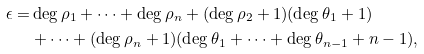Convert formula to latex. <formula><loc_0><loc_0><loc_500><loc_500>\epsilon = & \deg \rho _ { 1 } + \dots + \deg \rho _ { n } + ( \deg \rho _ { 2 } + 1 ) ( \deg \theta _ { 1 } + 1 ) \\ & + \dots + ( \deg \rho _ { n } + 1 ) ( \deg \theta _ { 1 } + \dots + \deg \theta _ { n - 1 } + n - 1 ) ,</formula> 